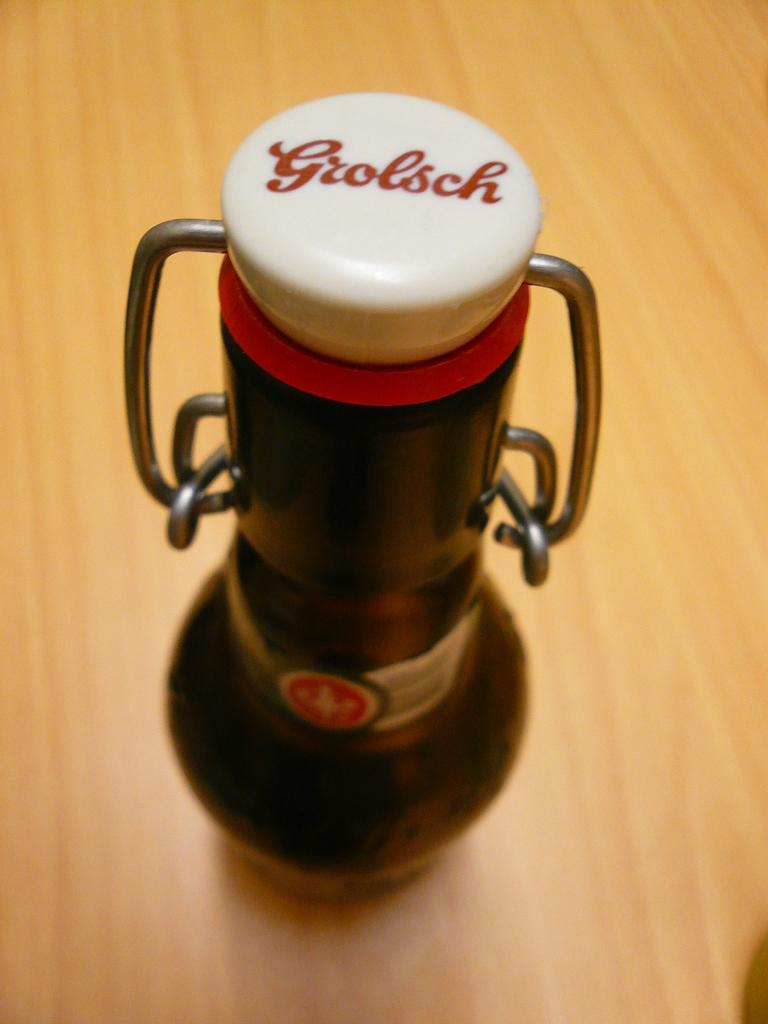<image>
Describe the image concisely. A bottle with a Grolsch logo is seen from above. 